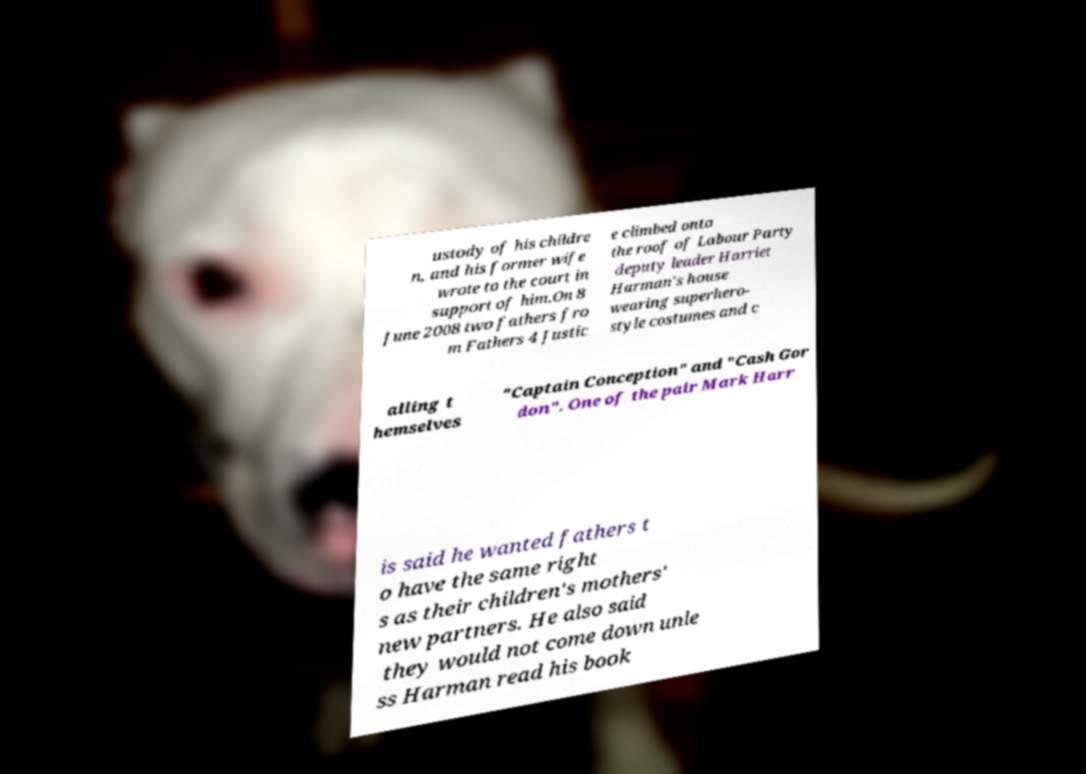Could you assist in decoding the text presented in this image and type it out clearly? ustody of his childre n, and his former wife wrote to the court in support of him.On 8 June 2008 two fathers fro m Fathers 4 Justic e climbed onto the roof of Labour Party deputy leader Harriet Harman's house wearing superhero- style costumes and c alling t hemselves "Captain Conception" and "Cash Gor don". One of the pair Mark Harr is said he wanted fathers t o have the same right s as their children's mothers' new partners. He also said they would not come down unle ss Harman read his book 